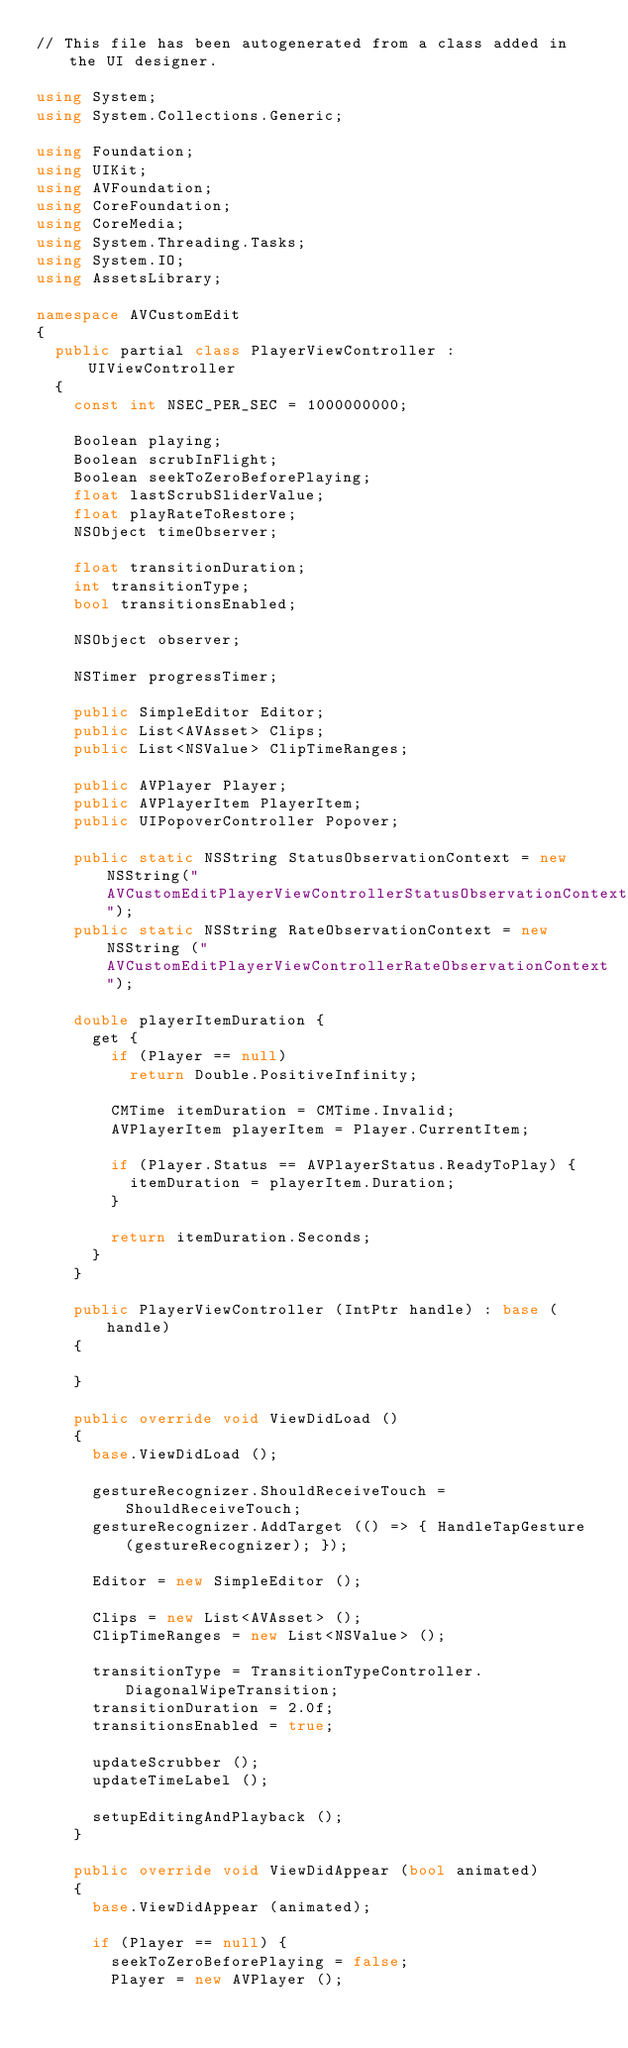Convert code to text. <code><loc_0><loc_0><loc_500><loc_500><_C#_>// This file has been autogenerated from a class added in the UI designer.

using System;
using System.Collections.Generic;

using Foundation;
using UIKit;
using AVFoundation;
using CoreFoundation;
using CoreMedia;
using System.Threading.Tasks;
using System.IO;
using AssetsLibrary;

namespace AVCustomEdit
{
	public partial class PlayerViewController : UIViewController
	{
		const int NSEC_PER_SEC = 1000000000;

		Boolean playing;
		Boolean scrubInFlight;
		Boolean seekToZeroBeforePlaying;
		float lastScrubSliderValue;
		float playRateToRestore;
		NSObject timeObserver;

		float transitionDuration;
		int transitionType;
		bool transitionsEnabled;

		NSObject observer;

		NSTimer progressTimer;

		public SimpleEditor Editor;
		public List<AVAsset> Clips;
		public List<NSValue> ClipTimeRanges;

		public AVPlayer Player;
		public AVPlayerItem PlayerItem;
		public UIPopoverController Popover;

		public static NSString StatusObservationContext = new NSString("AVCustomEditPlayerViewControllerStatusObservationContext");
		public static NSString RateObservationContext = new NSString ("AVCustomEditPlayerViewControllerRateObservationContext");

		double playerItemDuration {
			get {
				if (Player == null)
					return Double.PositiveInfinity;

				CMTime itemDuration = CMTime.Invalid;
				AVPlayerItem playerItem = Player.CurrentItem;

				if (Player.Status == AVPlayerStatus.ReadyToPlay) {
					itemDuration = playerItem.Duration;
				}

				return itemDuration.Seconds;
			}
		}

		public PlayerViewController (IntPtr handle) : base (handle)
		{

		}

		public override void ViewDidLoad ()
		{
			base.ViewDidLoad ();

			gestureRecognizer.ShouldReceiveTouch = ShouldReceiveTouch;
			gestureRecognizer.AddTarget (() => { HandleTapGesture (gestureRecognizer); });

			Editor = new SimpleEditor ();

			Clips = new List<AVAsset> ();
			ClipTimeRanges = new List<NSValue> ();

			transitionType = TransitionTypeController.DiagonalWipeTransition;
			transitionDuration = 2.0f;
			transitionsEnabled = true;

			updateScrubber ();
			updateTimeLabel ();

			setupEditingAndPlayback ();
		}

		public override void ViewDidAppear (bool animated)
		{
			base.ViewDidAppear (animated);

			if (Player == null) {
				seekToZeroBeforePlaying = false;
				Player = new AVPlayer ();</code> 